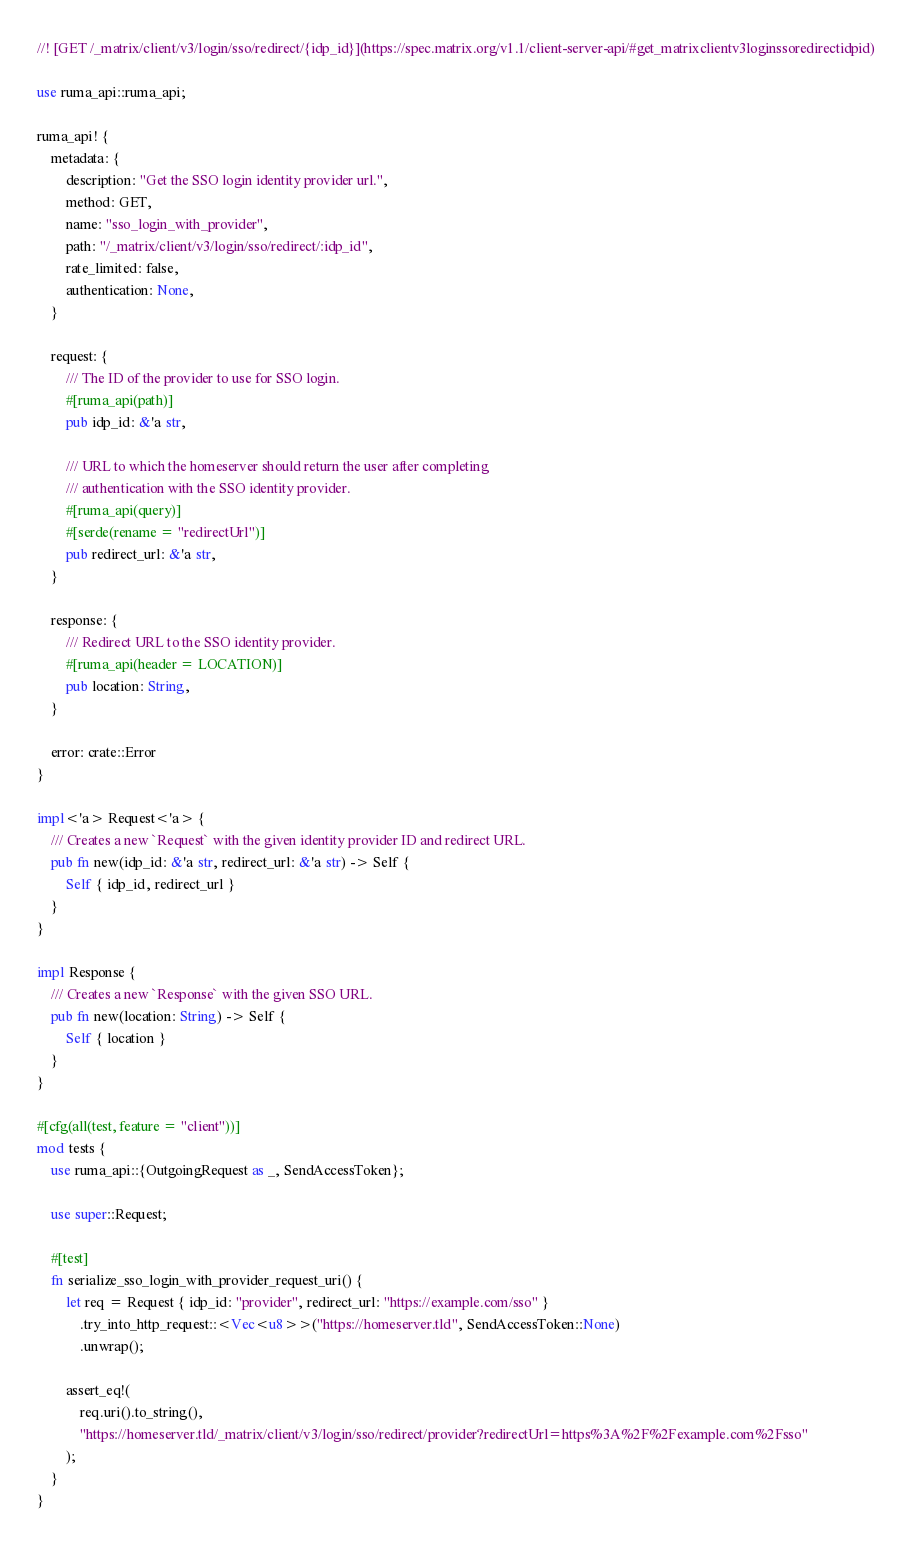Convert code to text. <code><loc_0><loc_0><loc_500><loc_500><_Rust_>//! [GET /_matrix/client/v3/login/sso/redirect/{idp_id}](https://spec.matrix.org/v1.1/client-server-api/#get_matrixclientv3loginssoredirectidpid)

use ruma_api::ruma_api;

ruma_api! {
    metadata: {
        description: "Get the SSO login identity provider url.",
        method: GET,
        name: "sso_login_with_provider",
        path: "/_matrix/client/v3/login/sso/redirect/:idp_id",
        rate_limited: false,
        authentication: None,
    }

    request: {
        /// The ID of the provider to use for SSO login.
        #[ruma_api(path)]
        pub idp_id: &'a str,

        /// URL to which the homeserver should return the user after completing
        /// authentication with the SSO identity provider.
        #[ruma_api(query)]
        #[serde(rename = "redirectUrl")]
        pub redirect_url: &'a str,
    }

    response: {
        /// Redirect URL to the SSO identity provider.
        #[ruma_api(header = LOCATION)]
        pub location: String,
    }

    error: crate::Error
}

impl<'a> Request<'a> {
    /// Creates a new `Request` with the given identity provider ID and redirect URL.
    pub fn new(idp_id: &'a str, redirect_url: &'a str) -> Self {
        Self { idp_id, redirect_url }
    }
}

impl Response {
    /// Creates a new `Response` with the given SSO URL.
    pub fn new(location: String) -> Self {
        Self { location }
    }
}

#[cfg(all(test, feature = "client"))]
mod tests {
    use ruma_api::{OutgoingRequest as _, SendAccessToken};

    use super::Request;

    #[test]
    fn serialize_sso_login_with_provider_request_uri() {
        let req = Request { idp_id: "provider", redirect_url: "https://example.com/sso" }
            .try_into_http_request::<Vec<u8>>("https://homeserver.tld", SendAccessToken::None)
            .unwrap();

        assert_eq!(
            req.uri().to_string(),
            "https://homeserver.tld/_matrix/client/v3/login/sso/redirect/provider?redirectUrl=https%3A%2F%2Fexample.com%2Fsso"
        );
    }
}
</code> 